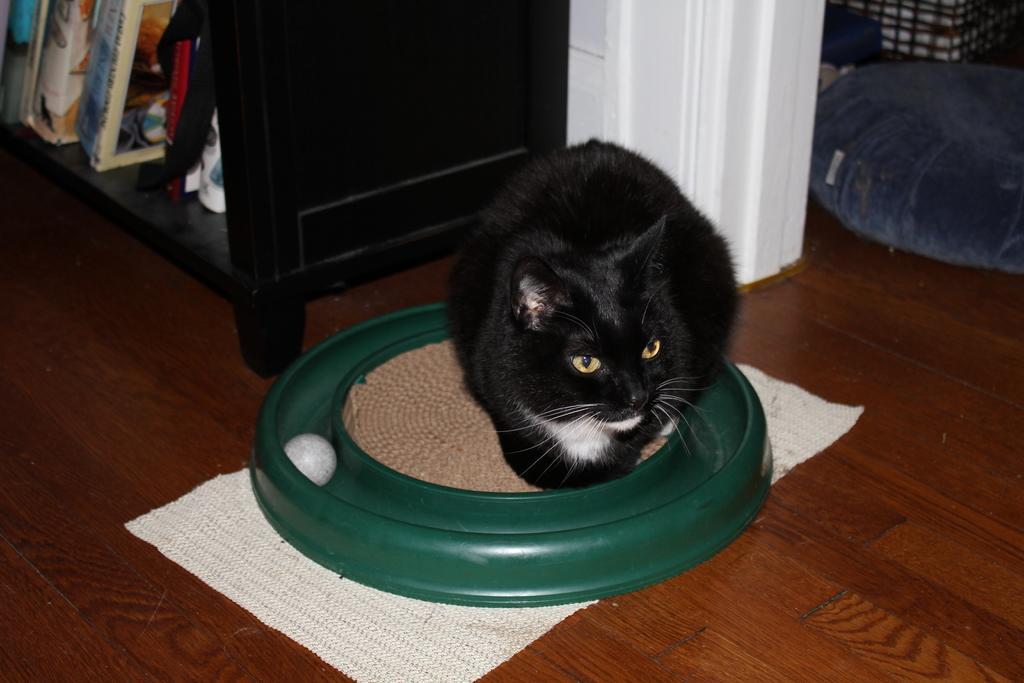Describe this image in one or two sentences. In this picture there is a black color cat sitting on the green color dish which is placed on the wooden flooring tile. Beside there is a wooden rack with some books in it. 